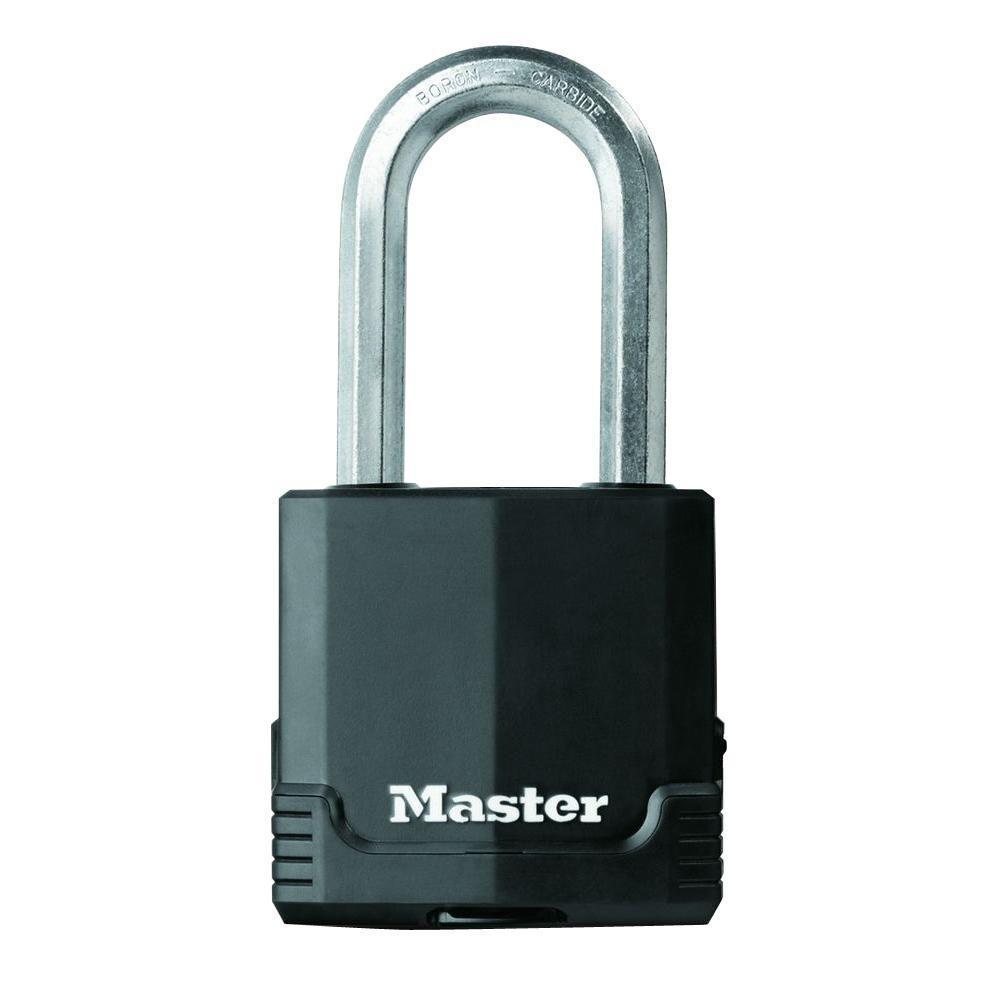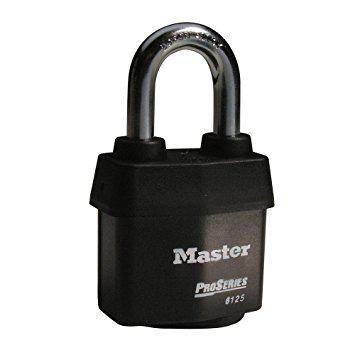The first image is the image on the left, the second image is the image on the right. Examine the images to the left and right. Is the description "There are four padlocks, all of which are closed." accurate? Answer yes or no. No. The first image is the image on the left, the second image is the image on the right. Evaluate the accuracy of this statement regarding the images: "Multiple keys are next to a pair of the same type locks in one image.". Is it true? Answer yes or no. No. 